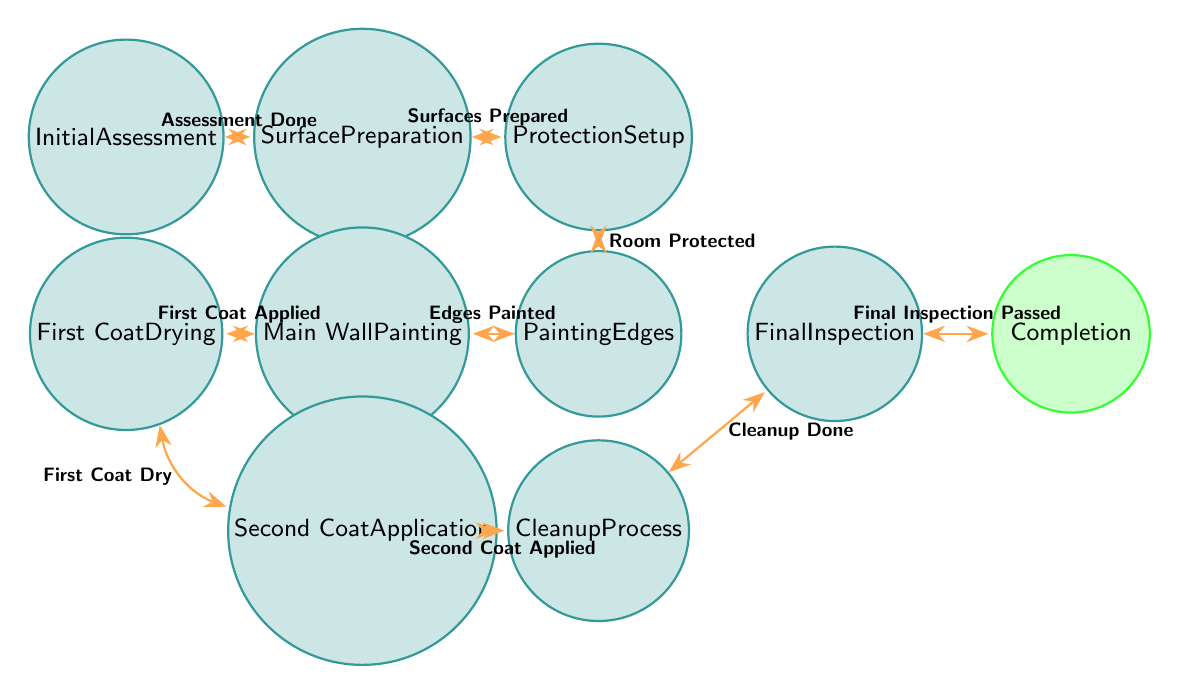What is the starting state of the painting process? The starting state is represented as the first node in the diagram, which is "Initial Assessment."
Answer: Initial Assessment How many states are there in the diagram? By counting the number of unique states listed in the diagram, we find there are ten states (1 to 10).
Answer: 10 What transition occurs after the 'Surface Preparation' state? The transition from 'Surface Preparation' leads to 'Protection Setup', as indicated in the transitions section.
Answer: Protection Setup Which state requires making sure "the paint is fully dry"? The state where ensuring the paint is fully dry is referred to is the last state, "Completion."
Answer: Completion What is the trigger for moving from 'First Coat Drying' to 'Second Coat Application'? The transition from 'First Coat Drying' to 'Second Coat Application' is triggered by "First Coat Dry."
Answer: First Coat Dry What is the final state after a successful 'Final Inspection'? After a successful 'Final Inspection', the process reaches the state of "Completion."
Answer: Completion Which state involves 'Cleaning up any spills or drips'? The state that involves cleaning up spills or drips is "Cleanup Process."
Answer: Cleanup Process Which transitions occur after 'Main Wall Painting'? Following 'Main Wall Painting', the transitions are 'First Coat Drying' and then 'Second Coat Application.' The transition is "First Coat Applied" for the first part.
Answer: First Coat Drying, Second Coat Application What is the requirement to move from 'Painting Edges' to 'Main Wall Painting'? To transition from 'Painting Edges' to 'Main Wall Painting', the edges must be painted, indicated by the trigger 'Edges Painted.'
Answer: Edges Painted 